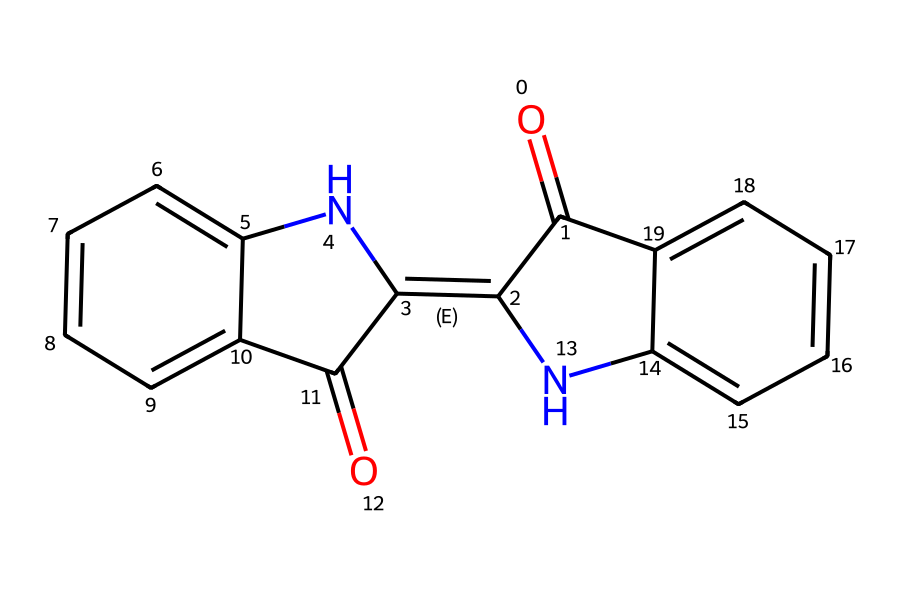What is the name of this chemical? The SMILES representation indicates the presence of an indigo structure, which is a well-known natural dye used in textiles. By breaking down the molecular structure, we observe the characteristic double bonds and the aromatic rings that are typical of indigo.
Answer: indigo How many rings are present in the structure? Analyzing the chemical structure reveals two distinct fused aromatic rings, making it a bicyclic compound. Each ring is evident in the SMILES notation, reflecting the planar structure of indigo.
Answer: two How many carbon atoms are in the molecule? Counting the carbon atoms in the structure, which includes the two aromatic rings and additional carbonyl groups, reveals a total of 14 carbon atoms present. This is deduced from the graphically visible carbon atoms in the drawn structure.
Answer: fourteen What type of bonds connect the atoms? The molecule shows a mix of double and single bonds, primarily due to the presence of carbon-carbon (C-C) and carbon-nitrogen (C-N) connections, as well as the carbonyl (C=O) bonds. Each bond type can be identified visually in the chemical structure derived from the SMILES notation.
Answer: double and single bonds Which functional group is present in this molecule? The presence of carbonyl groups (C=O) in the structure suggests that indigo contains functional groups characteristic of ketones, which significantly contribute to its chemical properties. These can be identified by their distinct representation in the SMILES format.
Answer: carbonyl group What does the nitrogen in the structure indicate about the compound? The nitrogen atoms in the fused aromatic rings suggest the potential for hydrogen bonding or interaction with other molecules, indicating that indigo has functionalities that may affect solubility and dye properties, derived from its placement in the chemical structure.
Answer: nitrogen 